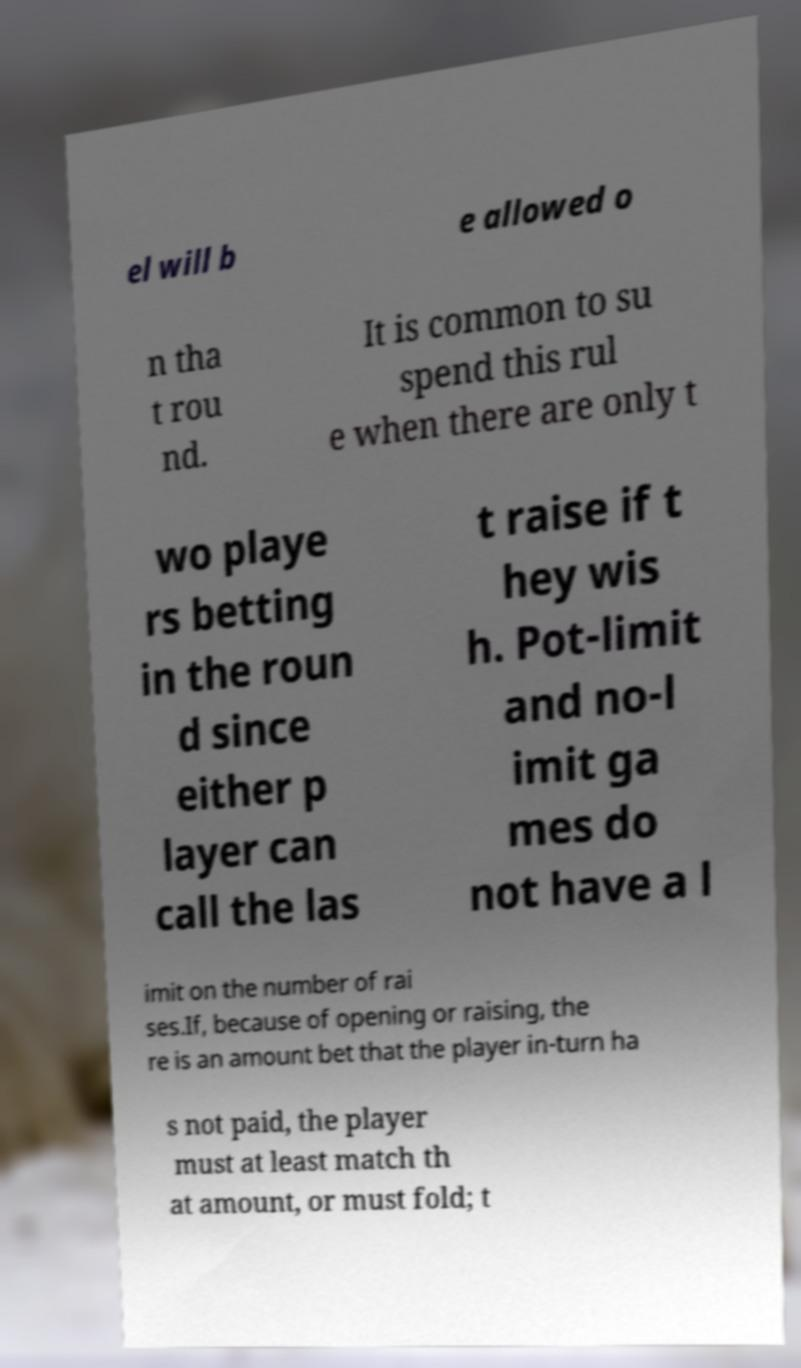Can you read and provide the text displayed in the image?This photo seems to have some interesting text. Can you extract and type it out for me? el will b e allowed o n tha t rou nd. It is common to su spend this rul e when there are only t wo playe rs betting in the roun d since either p layer can call the las t raise if t hey wis h. Pot-limit and no-l imit ga mes do not have a l imit on the number of rai ses.If, because of opening or raising, the re is an amount bet that the player in-turn ha s not paid, the player must at least match th at amount, or must fold; t 